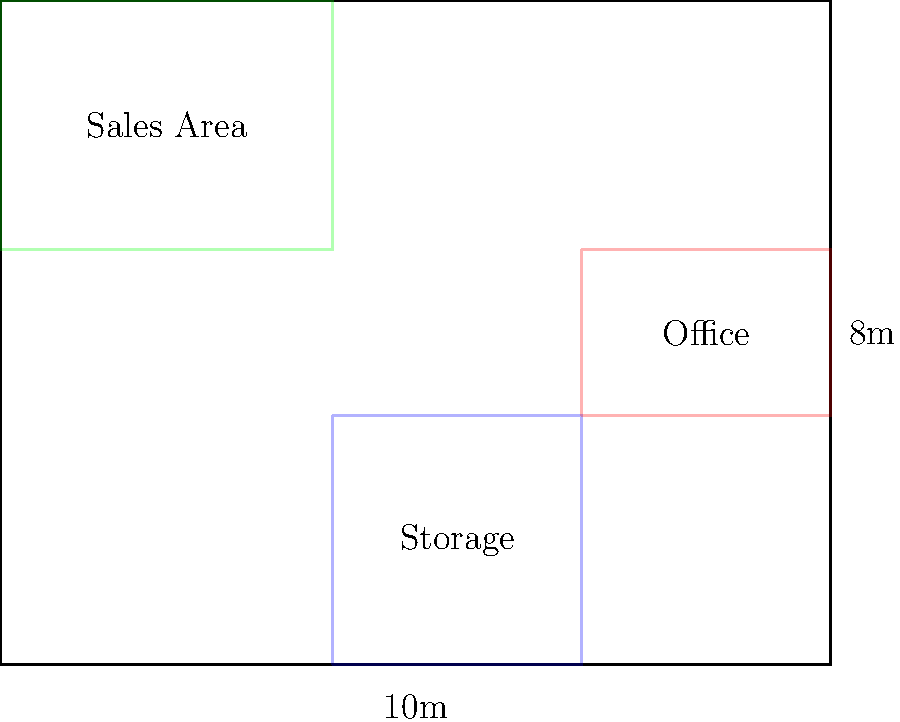Given the dispensary floor plan with dimensions of 10m x 8m, which area arrangement maximizes customer flow and operational efficiency? (Green: Sales Area, Blue: Storage, Red: Office) To determine the most efficient layout for a dispensary floor plan, we need to consider several factors:

1. Customer Flow: The sales area should be easily accessible and occupy the largest space to accommodate customers comfortably.

2. Security: The storage area should be separate from the sales area and easily monitored.

3. Staff Efficiency: The office should be positioned to oversee both the sales and storage areas.

4. Compliance: Ensure proper separation between public and restricted areas.

Analyzing the given layout:

1. Sales Area (Green): Located at the front, occupying about 50% of the total space. This allows for maximum customer interaction and product display.

2. Storage Area (Blue): Positioned at the back-left corner, separate from the sales area. This placement enhances security and allows for easy restocking.

3. Office Area (Red): Situated at the back-right corner, providing a clear view of both the sales and storage areas. This placement allows for effective oversight and management.

4. Traffic Flow: The layout creates a natural flow from entrance to exit, guiding customers through the sales area efficiently.

5. Compliance: The clear separation of public (sales) and restricted (storage and office) areas meets typical regulatory requirements.

This arrangement maximizes customer flow by providing ample space for product browsing and purchasing. It also enhances operational efficiency by strategically placing the storage and office areas for easy access and oversight.
Answer: The given layout maximizes efficiency with sales area in front, storage in back-left, and office in back-right. 